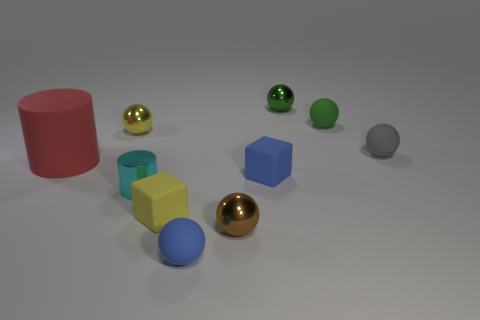Is there any other thing that has the same size as the yellow block?
Offer a very short reply. Yes. Is the color of the tiny cylinder the same as the large rubber cylinder?
Ensure brevity in your answer.  No. Is the number of yellow matte objects greater than the number of small green cylinders?
Your response must be concise. Yes. There is a small metallic sphere in front of the yellow shiny sphere; how many green rubber things are in front of it?
Your answer should be compact. 0. Are there any small shiny balls in front of the tiny cyan thing?
Offer a terse response. Yes. There is a thing that is behind the green object that is to the right of the tiny green metallic ball; what is its shape?
Your answer should be very brief. Sphere. Are there fewer big red matte cylinders right of the small cyan metallic cylinder than yellow cubes behind the yellow matte thing?
Offer a very short reply. No. What is the color of the other thing that is the same shape as the yellow matte object?
Give a very brief answer. Blue. What number of spheres are both behind the green rubber sphere and to the right of the small green rubber ball?
Offer a terse response. 0. Are there more tiny rubber spheres behind the yellow matte thing than cyan metal objects on the left side of the red rubber thing?
Your response must be concise. Yes. 